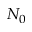Convert formula to latex. <formula><loc_0><loc_0><loc_500><loc_500>N _ { 0 }</formula> 